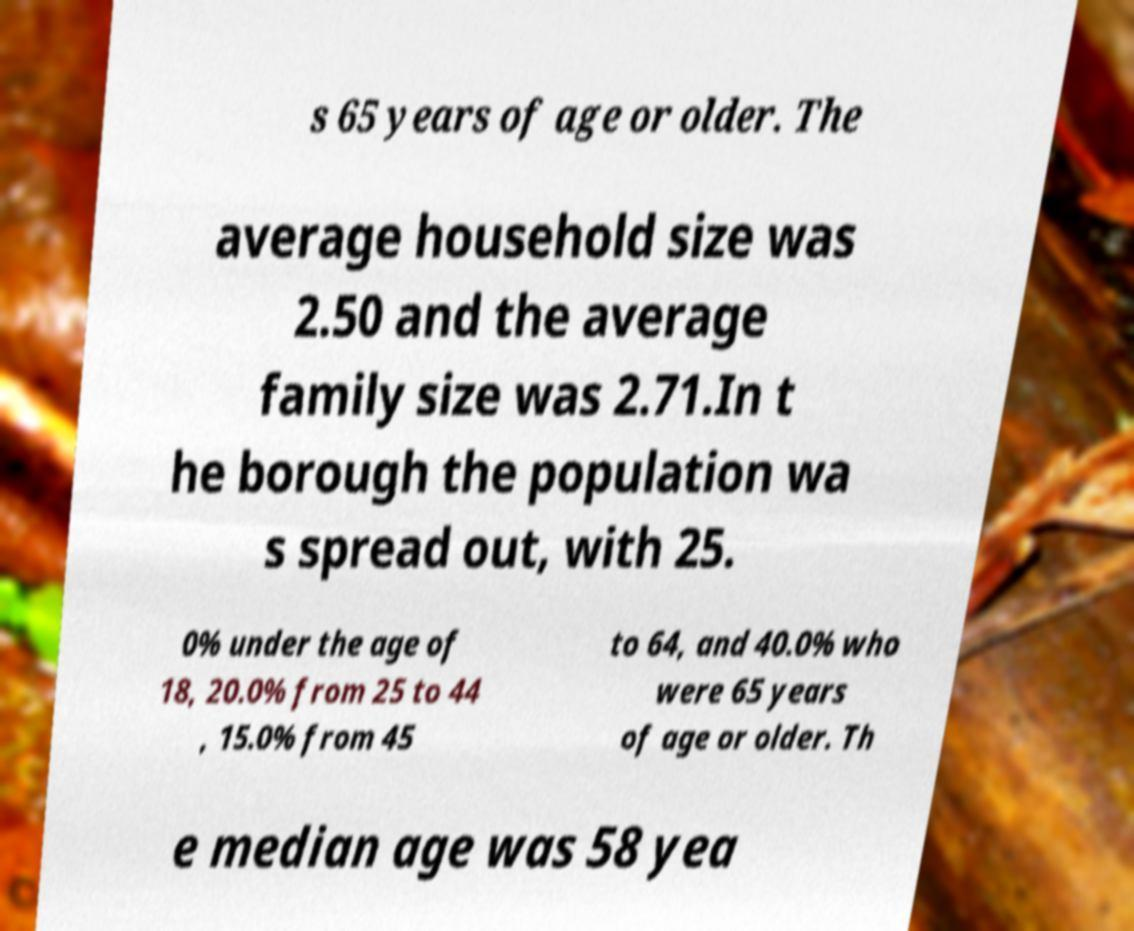Please read and relay the text visible in this image. What does it say? s 65 years of age or older. The average household size was 2.50 and the average family size was 2.71.In t he borough the population wa s spread out, with 25. 0% under the age of 18, 20.0% from 25 to 44 , 15.0% from 45 to 64, and 40.0% who were 65 years of age or older. Th e median age was 58 yea 